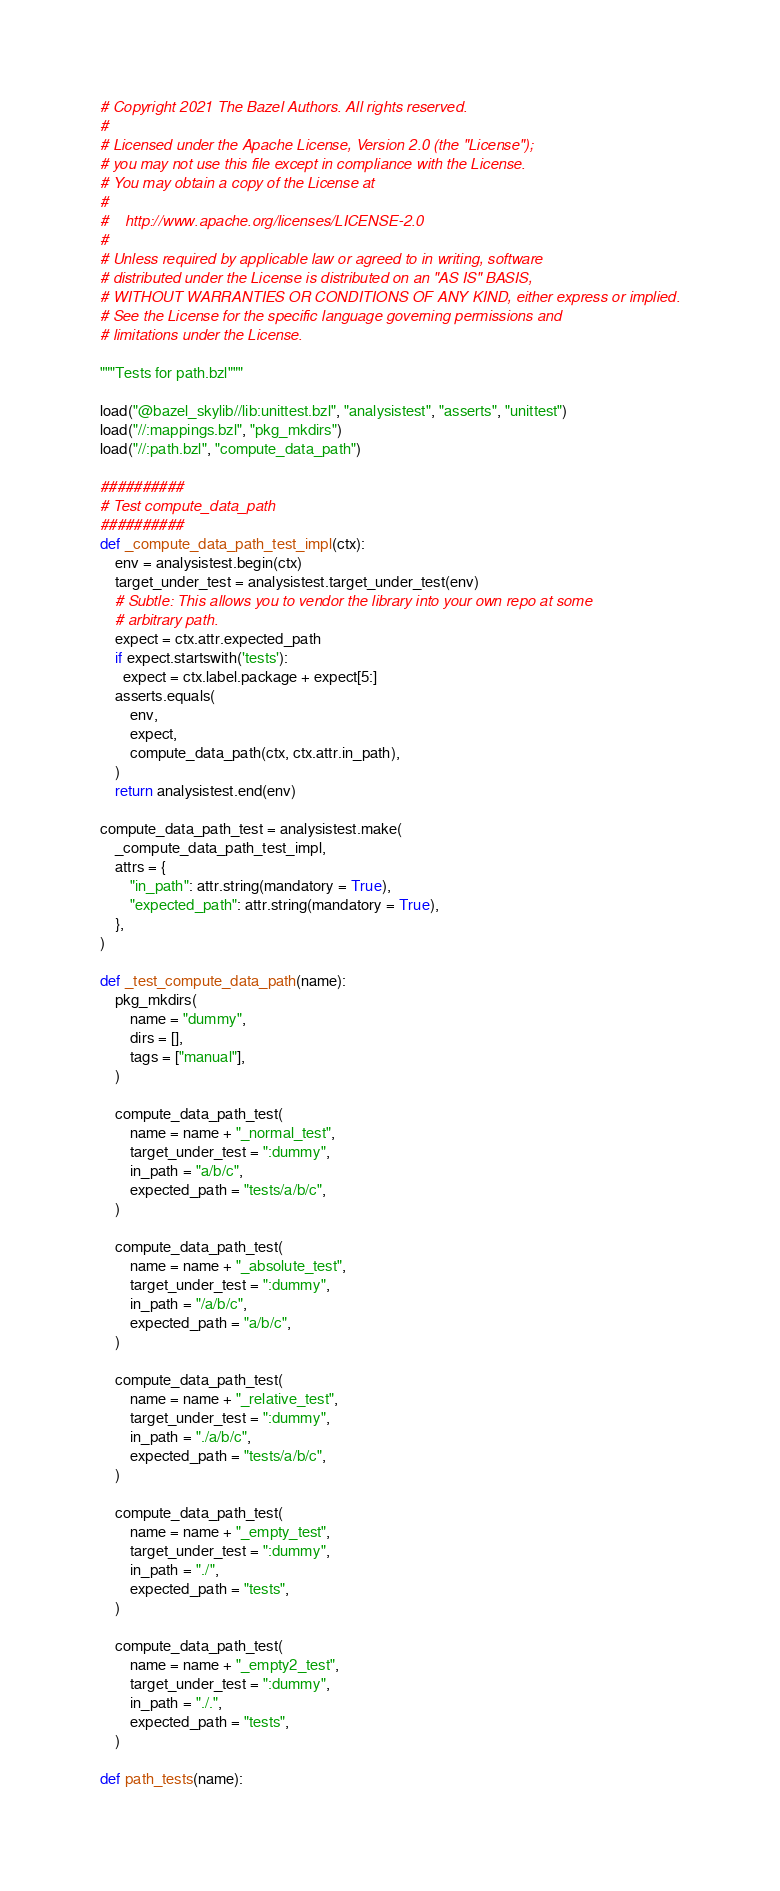Convert code to text. <code><loc_0><loc_0><loc_500><loc_500><_Python_># Copyright 2021 The Bazel Authors. All rights reserved.
#
# Licensed under the Apache License, Version 2.0 (the "License");
# you may not use this file except in compliance with the License.
# You may obtain a copy of the License at
#
#    http://www.apache.org/licenses/LICENSE-2.0
#
# Unless required by applicable law or agreed to in writing, software
# distributed under the License is distributed on an "AS IS" BASIS,
# WITHOUT WARRANTIES OR CONDITIONS OF ANY KIND, either express or implied.
# See the License for the specific language governing permissions and
# limitations under the License.

"""Tests for path.bzl"""

load("@bazel_skylib//lib:unittest.bzl", "analysistest", "asserts", "unittest")
load("//:mappings.bzl", "pkg_mkdirs")
load("//:path.bzl", "compute_data_path")

##########
# Test compute_data_path
##########
def _compute_data_path_test_impl(ctx):
    env = analysistest.begin(ctx)
    target_under_test = analysistest.target_under_test(env)
    # Subtle: This allows you to vendor the library into your own repo at some
    # arbitrary path.
    expect = ctx.attr.expected_path
    if expect.startswith('tests'):
      expect = ctx.label.package + expect[5:]
    asserts.equals(
        env,
        expect, 
        compute_data_path(ctx, ctx.attr.in_path),
    )
    return analysistest.end(env)

compute_data_path_test = analysistest.make(
    _compute_data_path_test_impl,
    attrs = {
        "in_path": attr.string(mandatory = True),
        "expected_path": attr.string(mandatory = True),
    },
)

def _test_compute_data_path(name):
    pkg_mkdirs(
        name = "dummy",
        dirs = [],
        tags = ["manual"],
    )

    compute_data_path_test(
        name = name + "_normal_test",
        target_under_test = ":dummy",
        in_path = "a/b/c",
        expected_path = "tests/a/b/c",
    )

    compute_data_path_test(
        name = name + "_absolute_test",
        target_under_test = ":dummy",
        in_path = "/a/b/c",
        expected_path = "a/b/c",
    )

    compute_data_path_test(
        name = name + "_relative_test",
        target_under_test = ":dummy",
        in_path = "./a/b/c",
        expected_path = "tests/a/b/c",
    )

    compute_data_path_test(
        name = name + "_empty_test",
        target_under_test = ":dummy",
        in_path = "./",
        expected_path = "tests",
    )

    compute_data_path_test(
        name = name + "_empty2_test",
        target_under_test = ":dummy",
        in_path = "./.",
        expected_path = "tests",
    )

def path_tests(name):</code> 